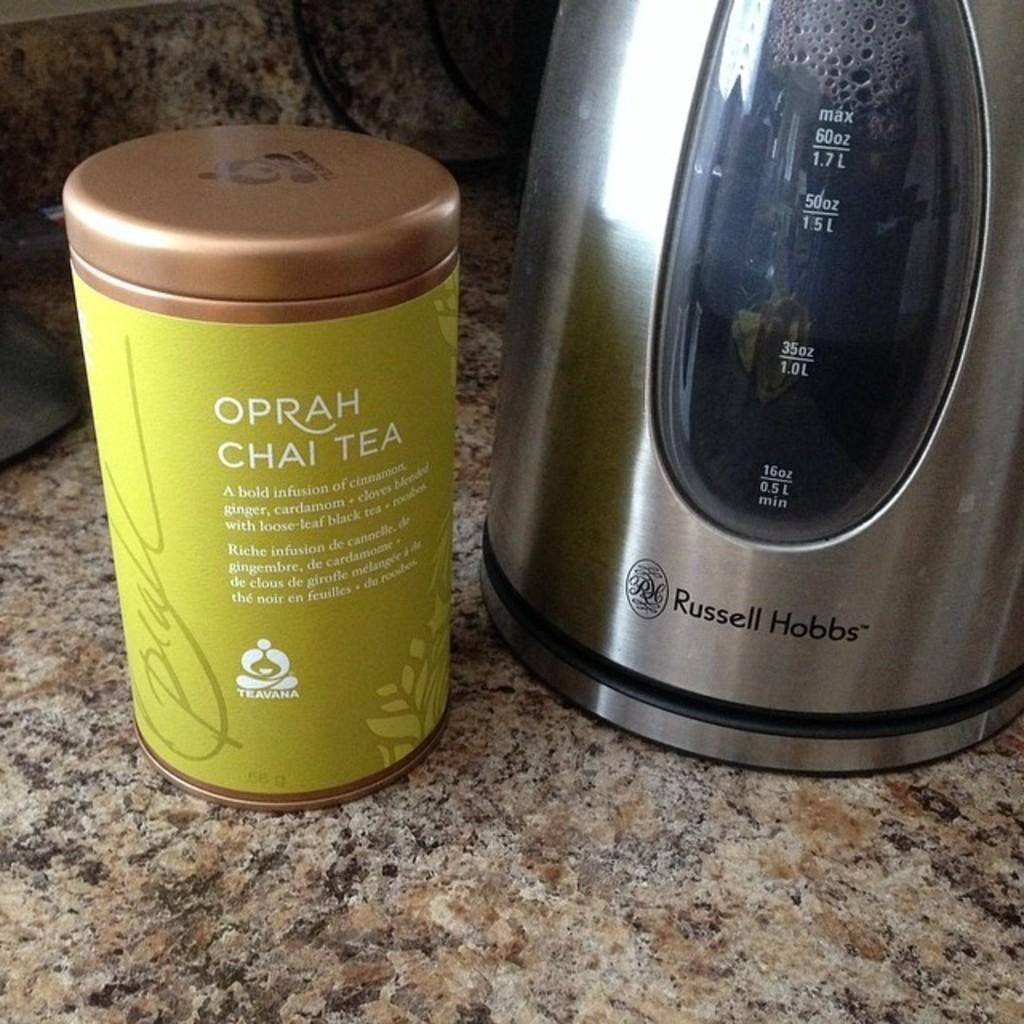Provide a one-sentence caption for the provided image. Container of Oprah's Chai Tea and a Russel Hobbs tea kettle to make it in. 